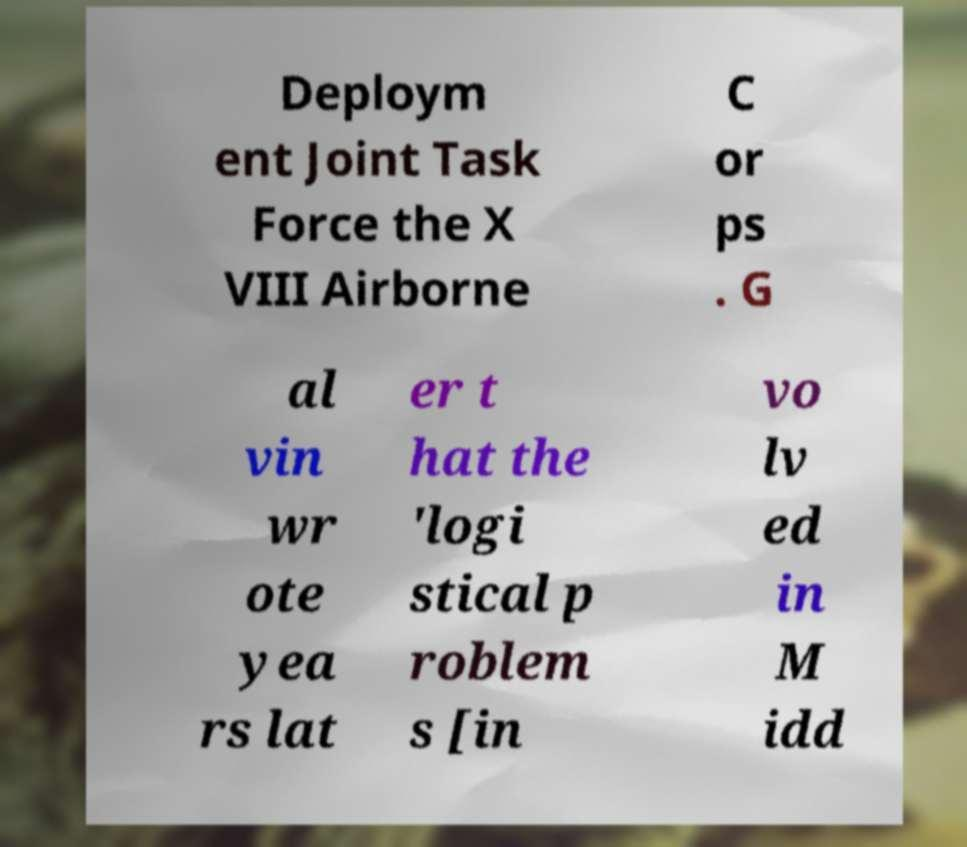There's text embedded in this image that I need extracted. Can you transcribe it verbatim? Deploym ent Joint Task Force the X VIII Airborne C or ps . G al vin wr ote yea rs lat er t hat the 'logi stical p roblem s [in vo lv ed in M idd 